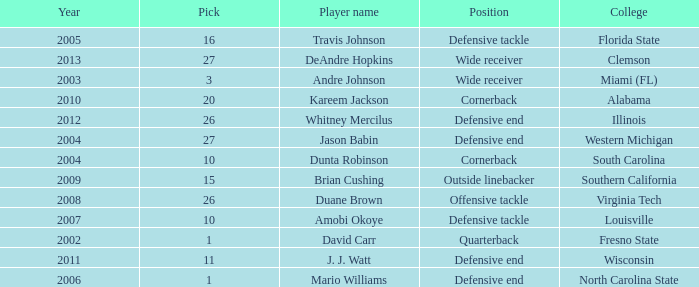Parse the table in full. {'header': ['Year', 'Pick', 'Player name', 'Position', 'College'], 'rows': [['2005', '16', 'Travis Johnson', 'Defensive tackle', 'Florida State'], ['2013', '27', 'DeAndre Hopkins', 'Wide receiver', 'Clemson'], ['2003', '3', 'Andre Johnson', 'Wide receiver', 'Miami (FL)'], ['2010', '20', 'Kareem Jackson', 'Cornerback', 'Alabama'], ['2012', '26', 'Whitney Mercilus', 'Defensive end', 'Illinois'], ['2004', '27', 'Jason Babin', 'Defensive end', 'Western Michigan'], ['2004', '10', 'Dunta Robinson', 'Cornerback', 'South Carolina'], ['2009', '15', 'Brian Cushing', 'Outside linebacker', 'Southern California'], ['2008', '26', 'Duane Brown', 'Offensive tackle', 'Virginia Tech'], ['2007', '10', 'Amobi Okoye', 'Defensive tackle', 'Louisville'], ['2002', '1', 'David Carr', 'Quarterback', 'Fresno State'], ['2011', '11', 'J. J. Watt', 'Defensive end', 'Wisconsin'], ['2006', '1', 'Mario Williams', 'Defensive end', 'North Carolina State']]} What pick was mario williams before 2006? None. 